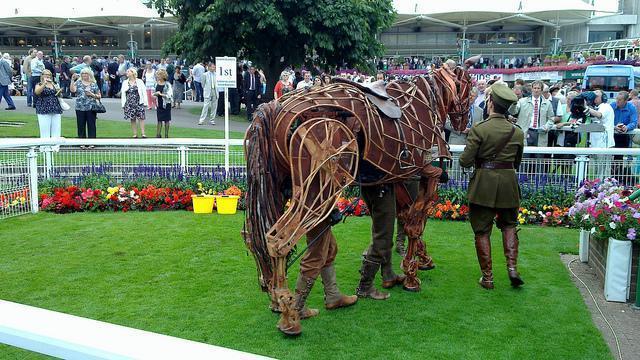What is inside of the horse sculpture?
From the following four choices, select the correct answer to address the question.
Options: Dogs, fish, food, humans. Humans. 